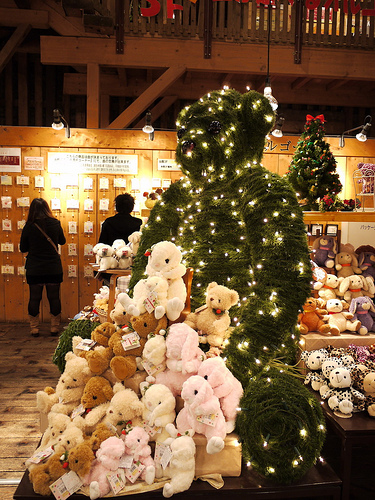<image>What store are these bears from? I don't know what store these bears are from. They could be from "Macy's", "FAO Schwartz", "Christmas Shoppe", "Build Bear", or some other store. What store are these bears from? It is not known what store these bears are from. It could be Macy's, FAO Schwartz, or a Christmas store. 